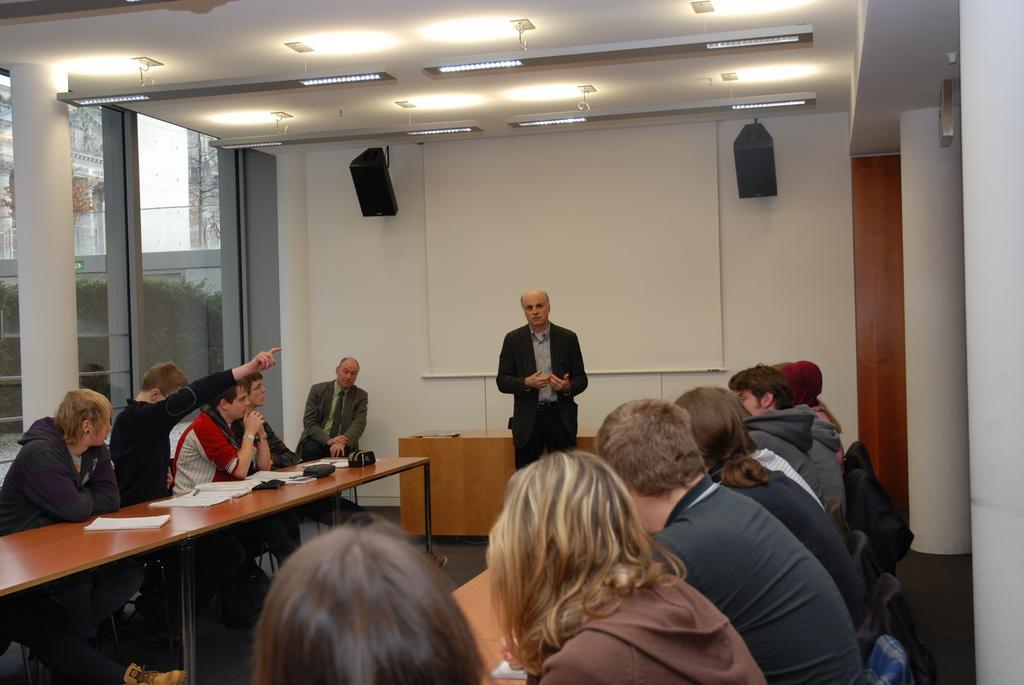Could you give a brief overview of what you see in this image? This image is clicked in a meeting room. There are many persons in this image. In the middle, there is a man standing and wearing black suit is talking. In the background there is a wall on which there are speakers and a screen. At the top there is a roof along with lights. There are many tables in this room. To the right, there are pillars. 